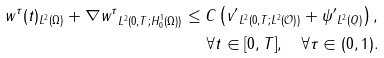<formula> <loc_0><loc_0><loc_500><loc_500>\| w ^ { \tau } ( t ) \| _ { L ^ { 2 } ( \Omega ) } + \| \nabla w ^ { \tau } \| _ { L ^ { 2 } ( 0 , T ; H _ { 0 } ^ { 1 } ( \Omega ) ) } \leq C \left ( \| v ^ { \prime } \| _ { L ^ { 2 } ( 0 , T ; L ^ { 2 } ( \mathcal { O } ) ) } + \| \psi ^ { \prime } \| _ { L ^ { 2 } ( Q ) } \right ) , \\ \forall t \in [ 0 , T ] , \quad \forall \tau \in ( 0 , 1 ) .</formula> 